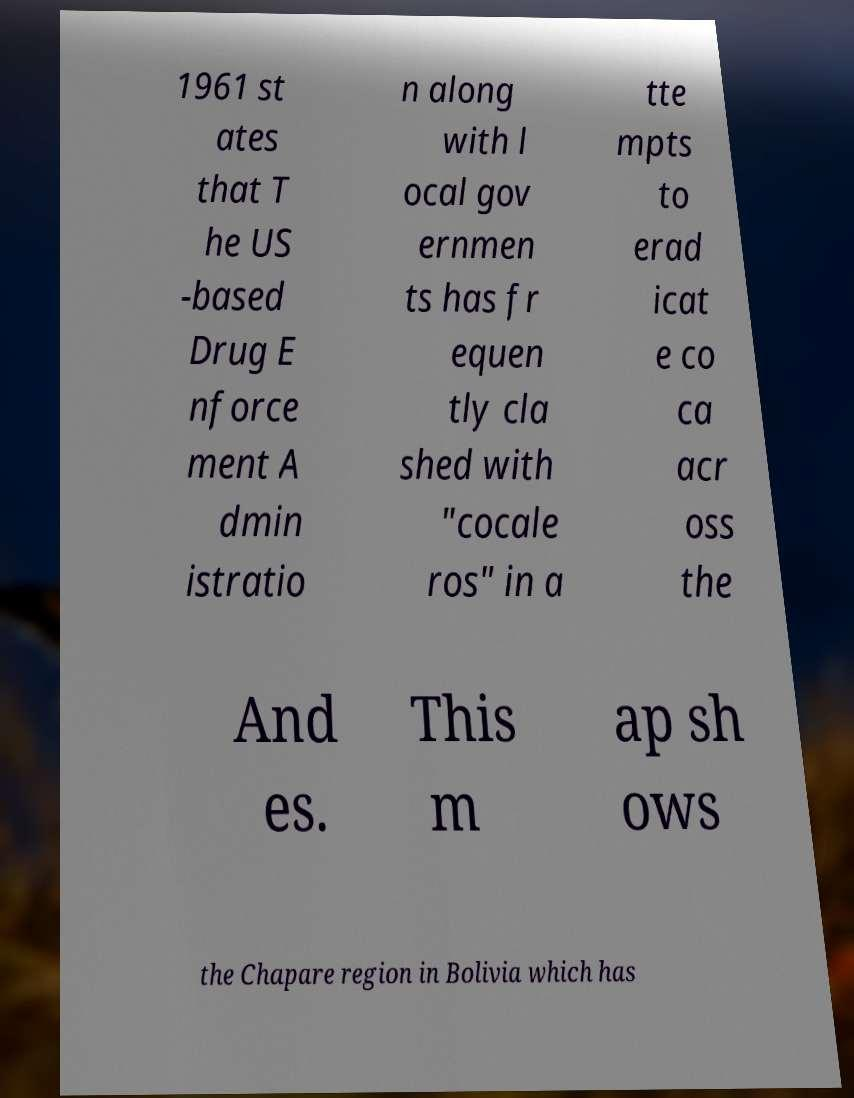Can you read and provide the text displayed in the image?This photo seems to have some interesting text. Can you extract and type it out for me? 1961 st ates that T he US -based Drug E nforce ment A dmin istratio n along with l ocal gov ernmen ts has fr equen tly cla shed with "cocale ros" in a tte mpts to erad icat e co ca acr oss the And es. This m ap sh ows the Chapare region in Bolivia which has 